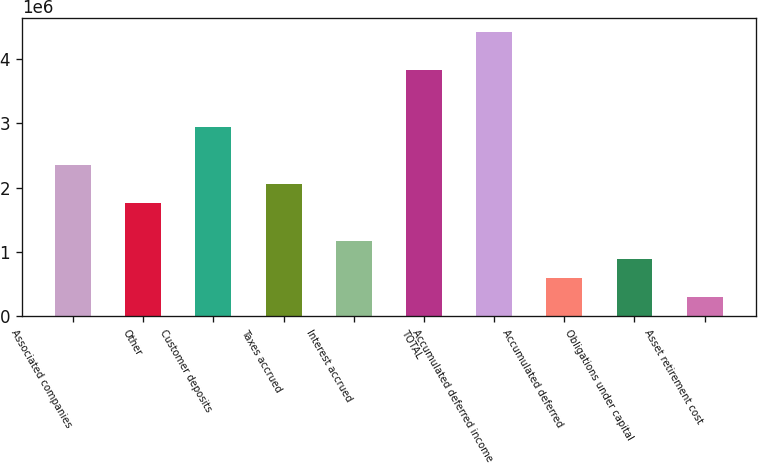Convert chart. <chart><loc_0><loc_0><loc_500><loc_500><bar_chart><fcel>Associated companies<fcel>Other<fcel>Customer deposits<fcel>Taxes accrued<fcel>Interest accrued<fcel>TOTAL<fcel>Accumulated deferred income<fcel>Accumulated deferred<fcel>Obligations under capital<fcel>Asset retirement cost<nl><fcel>2.35485e+06<fcel>1.76631e+06<fcel>2.94339e+06<fcel>2.06058e+06<fcel>1.17777e+06<fcel>3.82621e+06<fcel>4.41475e+06<fcel>589231<fcel>883501<fcel>294960<nl></chart> 